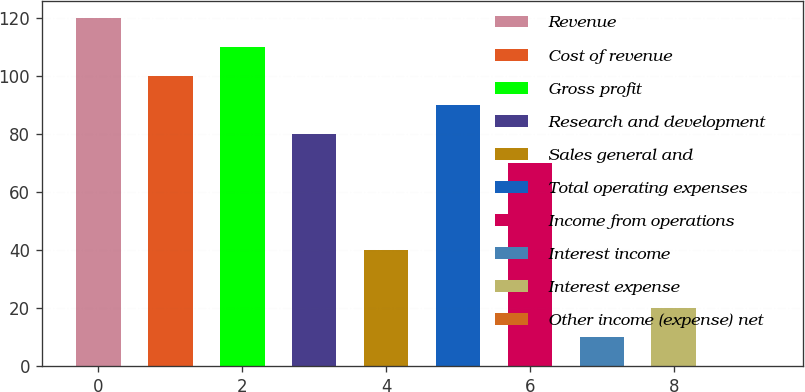<chart> <loc_0><loc_0><loc_500><loc_500><bar_chart><fcel>Revenue<fcel>Cost of revenue<fcel>Gross profit<fcel>Research and development<fcel>Sales general and<fcel>Total operating expenses<fcel>Income from operations<fcel>Interest income<fcel>Interest expense<fcel>Other income (expense) net<nl><fcel>119.94<fcel>100<fcel>109.97<fcel>80.06<fcel>40.18<fcel>90.03<fcel>70.09<fcel>10.27<fcel>20.24<fcel>0.3<nl></chart> 